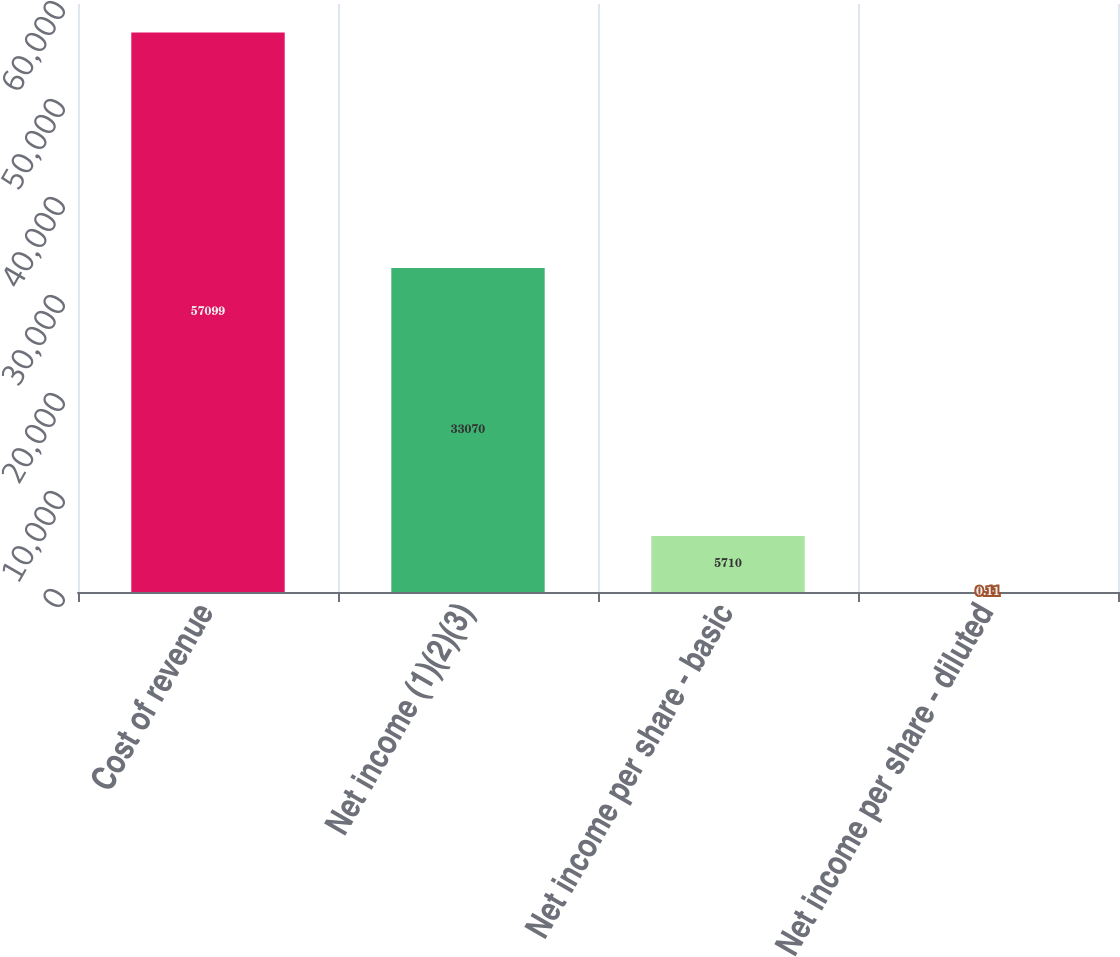<chart> <loc_0><loc_0><loc_500><loc_500><bar_chart><fcel>Cost of revenue<fcel>Net income (1)(2)(3)<fcel>Net income per share - basic<fcel>Net income per share - diluted<nl><fcel>57099<fcel>33070<fcel>5710<fcel>0.11<nl></chart> 